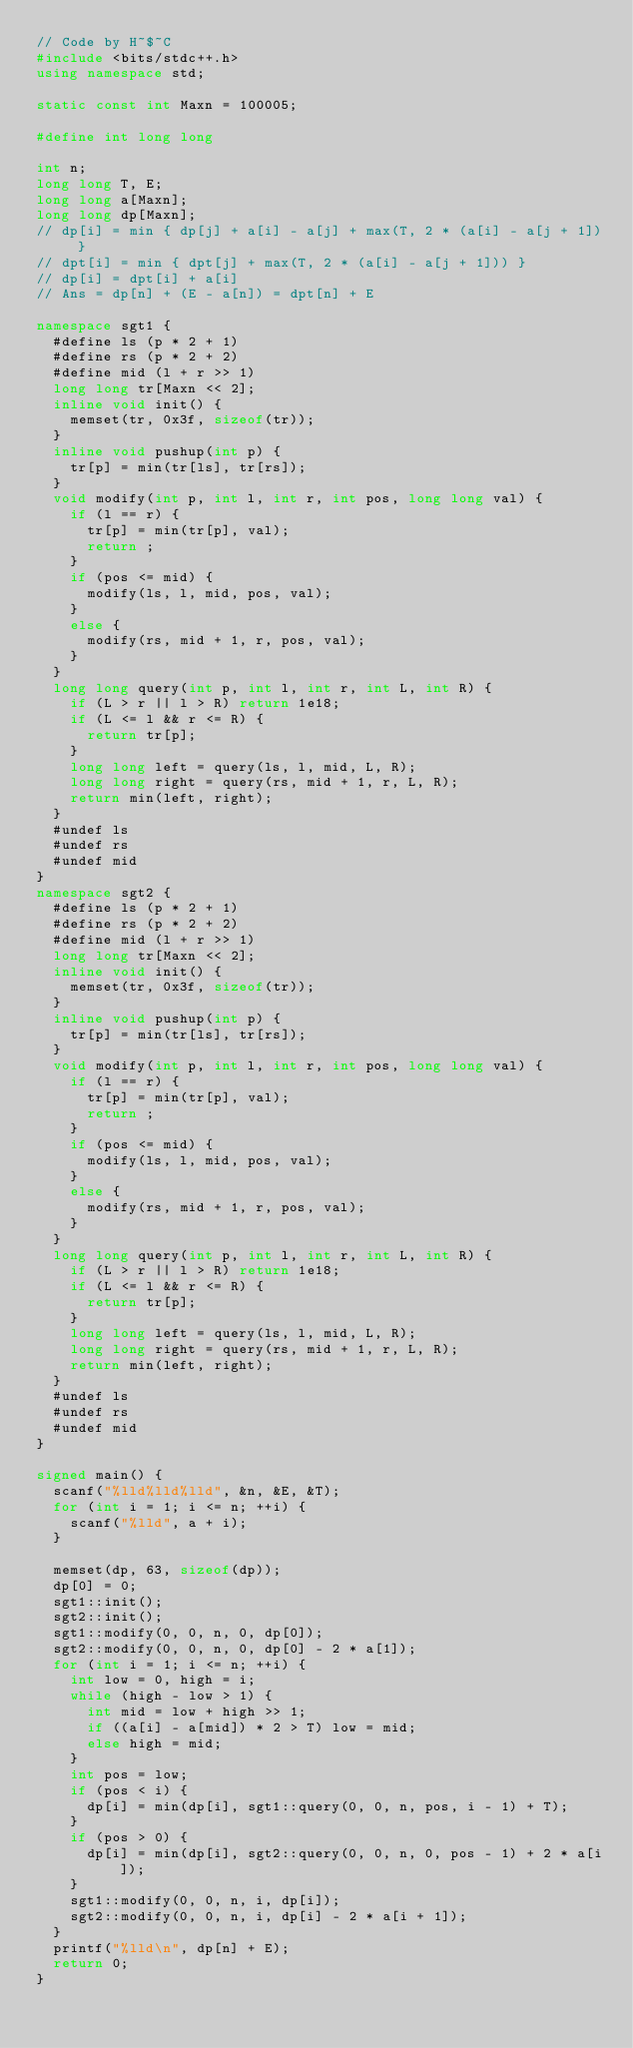<code> <loc_0><loc_0><loc_500><loc_500><_C++_>// Code by H~$~C
#include <bits/stdc++.h>
using namespace std;

static const int Maxn = 100005;

#define int long long

int n;
long long T, E;
long long a[Maxn];
long long dp[Maxn];
// dp[i] = min { dp[j] + a[i] - a[j] + max(T, 2 * (a[i] - a[j + 1]) }
// dpt[i] = min { dpt[j] + max(T, 2 * (a[i] - a[j + 1])) }
// dp[i] = dpt[i] + a[i]
// Ans = dp[n] + (E - a[n]) = dpt[n] + E

namespace sgt1 {
  #define ls (p * 2 + 1)
  #define rs (p * 2 + 2)
  #define mid (l + r >> 1)
  long long tr[Maxn << 2];
  inline void init() {
    memset(tr, 0x3f, sizeof(tr));
  }
  inline void pushup(int p) {
    tr[p] = min(tr[ls], tr[rs]);
  }
  void modify(int p, int l, int r, int pos, long long val) {
    if (l == r) {
      tr[p] = min(tr[p], val);
      return ;
    }
    if (pos <= mid) {
      modify(ls, l, mid, pos, val);
    }
    else {
      modify(rs, mid + 1, r, pos, val);
    }
  }
  long long query(int p, int l, int r, int L, int R) {
    if (L > r || l > R) return 1e18;
    if (L <= l && r <= R) {
      return tr[p];
    }
    long long left = query(ls, l, mid, L, R);
    long long right = query(rs, mid + 1, r, L, R);
    return min(left, right);
  }
  #undef ls
  #undef rs
  #undef mid
}
namespace sgt2 {
  #define ls (p * 2 + 1)
  #define rs (p * 2 + 2)
  #define mid (l + r >> 1)
  long long tr[Maxn << 2];
  inline void init() {
    memset(tr, 0x3f, sizeof(tr));
  }
  inline void pushup(int p) {
    tr[p] = min(tr[ls], tr[rs]);
  }
  void modify(int p, int l, int r, int pos, long long val) {
    if (l == r) {
      tr[p] = min(tr[p], val);
      return ;
    }
    if (pos <= mid) {
      modify(ls, l, mid, pos, val);
    }
    else {
      modify(rs, mid + 1, r, pos, val);
    }
  }
  long long query(int p, int l, int r, int L, int R) {
    if (L > r || l > R) return 1e18;
    if (L <= l && r <= R) {
      return tr[p];
    }
    long long left = query(ls, l, mid, L, R);
    long long right = query(rs, mid + 1, r, L, R);
    return min(left, right);
  }
  #undef ls
  #undef rs
  #undef mid
}

signed main() {
  scanf("%lld%lld%lld", &n, &E, &T);
  for (int i = 1; i <= n; ++i) {
    scanf("%lld", a + i);
  }
  
  memset(dp, 63, sizeof(dp));
  dp[0] = 0;
  sgt1::init();
  sgt2::init();
  sgt1::modify(0, 0, n, 0, dp[0]);
  sgt2::modify(0, 0, n, 0, dp[0] - 2 * a[1]);
  for (int i = 1; i <= n; ++i) {
    int low = 0, high = i;
    while (high - low > 1) {
      int mid = low + high >> 1;
      if ((a[i] - a[mid]) * 2 > T) low = mid;
      else high = mid;
    }
    int pos = low;
    if (pos < i) {
      dp[i] = min(dp[i], sgt1::query(0, 0, n, pos, i - 1) + T);
    }
    if (pos > 0) {
      dp[i] = min(dp[i], sgt2::query(0, 0, n, 0, pos - 1) + 2 * a[i]);
    }
    sgt1::modify(0, 0, n, i, dp[i]);
    sgt2::modify(0, 0, n, i, dp[i] - 2 * a[i + 1]);
  }
  printf("%lld\n", dp[n] + E);
  return 0;
}
</code> 